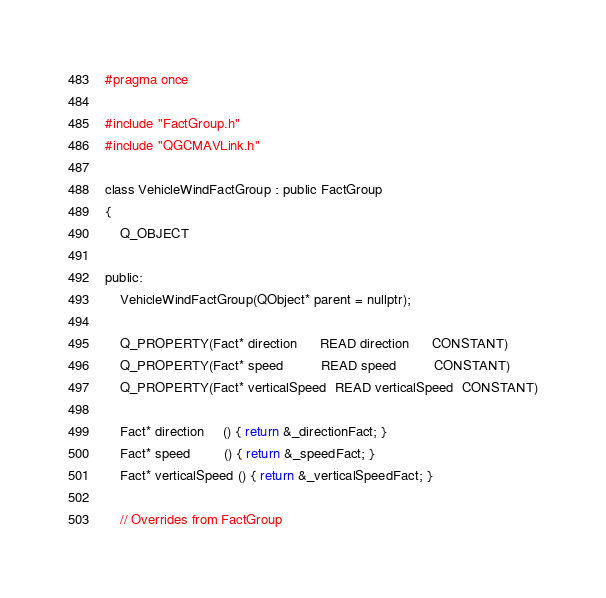Convert code to text. <code><loc_0><loc_0><loc_500><loc_500><_C_>
#pragma once

#include "FactGroup.h"
#include "QGCMAVLink.h"

class VehicleWindFactGroup : public FactGroup
{
    Q_OBJECT

public:
    VehicleWindFactGroup(QObject* parent = nullptr);

    Q_PROPERTY(Fact* direction      READ direction      CONSTANT)
    Q_PROPERTY(Fact* speed          READ speed          CONSTANT)
    Q_PROPERTY(Fact* verticalSpeed  READ verticalSpeed  CONSTANT)

    Fact* direction     () { return &_directionFact; }
    Fact* speed         () { return &_speedFact; }
    Fact* verticalSpeed () { return &_verticalSpeedFact; }

    // Overrides from FactGroup</code> 